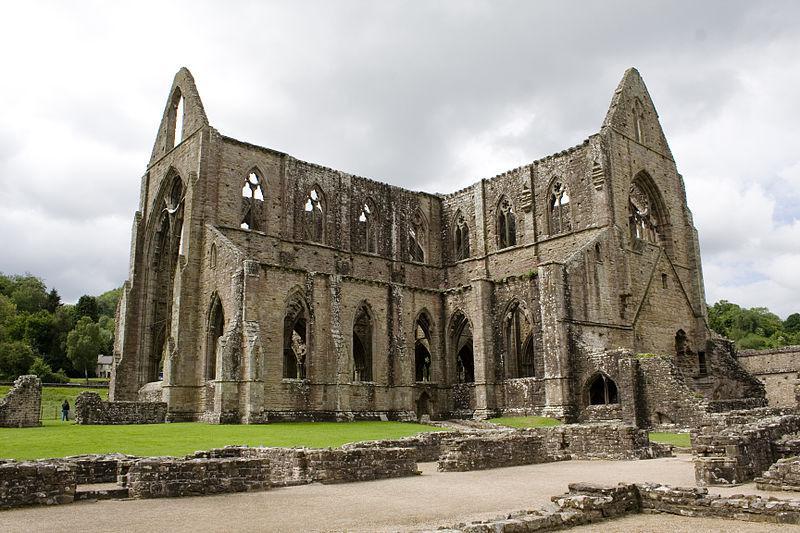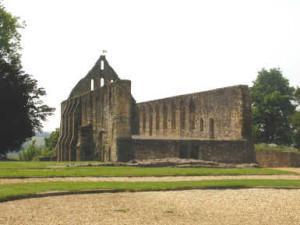The first image is the image on the left, the second image is the image on the right. Assess this claim about the two images: "There are no trees near any of the buidlings pictured.". Correct or not? Answer yes or no. No. The first image is the image on the left, the second image is the image on the right. For the images shown, is this caption "In one image, a large arched opening reaches several stories, almost to the roof line, and is topped with a pointed stone which has a window opening." true? Answer yes or no. Yes. 